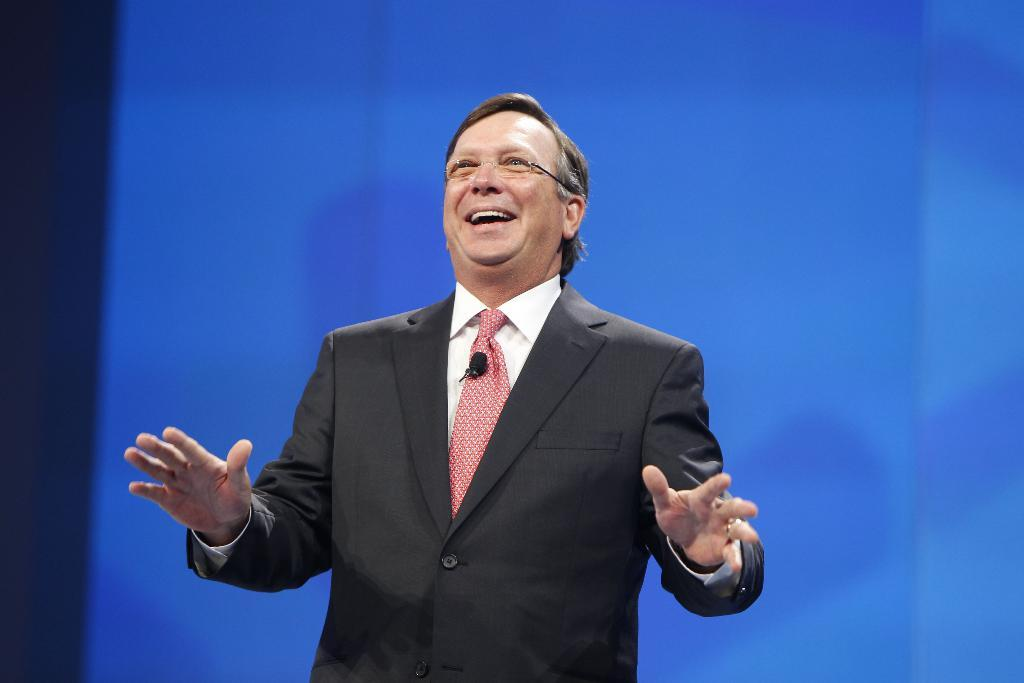What is the man in the image wearing? The man is wearing a blazer, a shirt, a tie, and spectacles. What is the man holding in the image? The man is holding a microphone in the image. What is the color of the background in the image? The background of the image is blue in color. What type of sack can be seen in the image? There is no sack present in the image. What is the texture of the man's blazer in the image? The provided facts do not mention the texture of the man's blazer, so it cannot be determined from the image. 